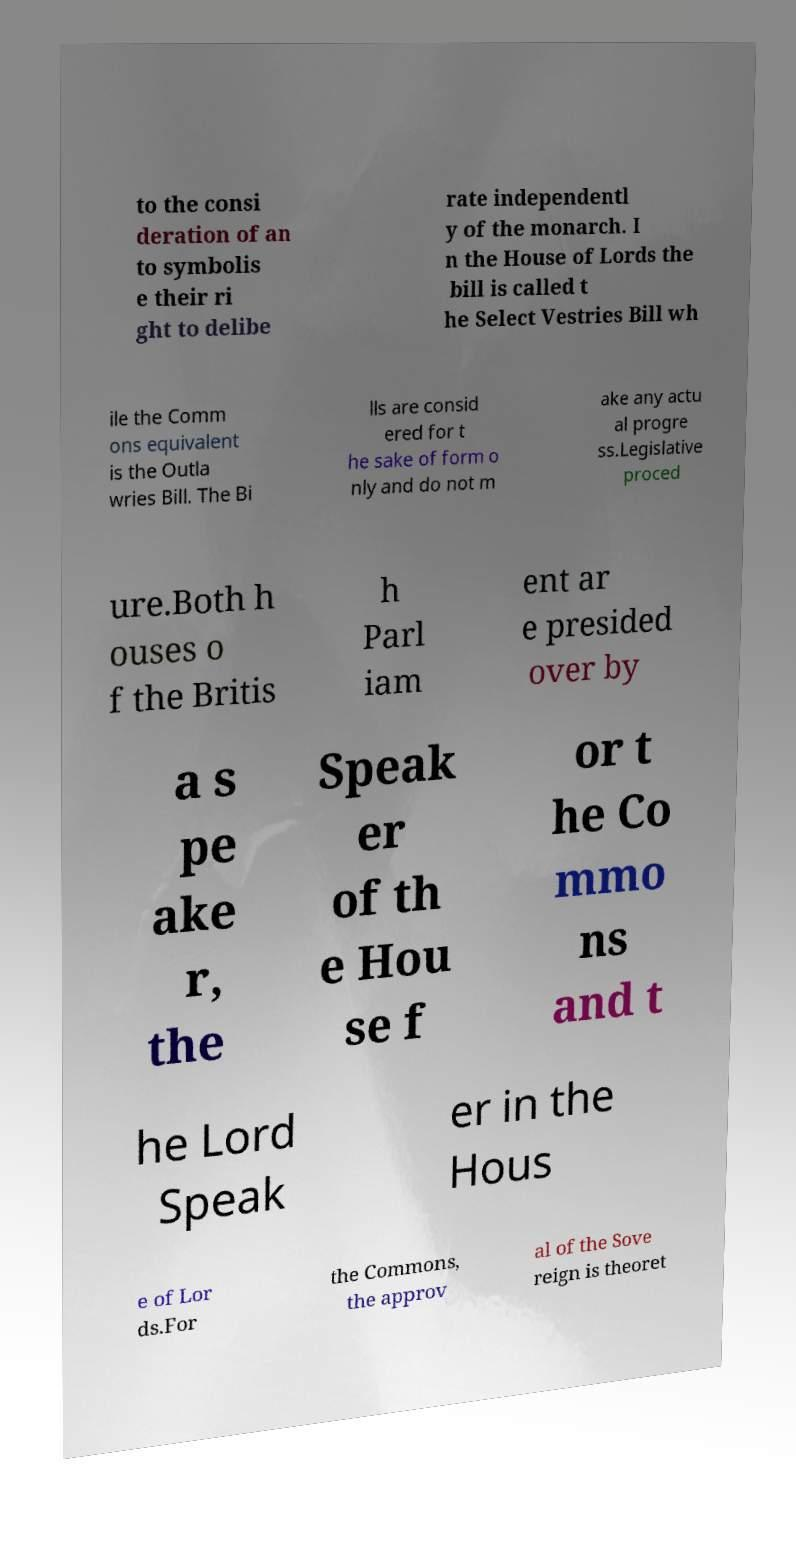Please read and relay the text visible in this image. What does it say? to the consi deration of an to symbolis e their ri ght to delibe rate independentl y of the monarch. I n the House of Lords the bill is called t he Select Vestries Bill wh ile the Comm ons equivalent is the Outla wries Bill. The Bi lls are consid ered for t he sake of form o nly and do not m ake any actu al progre ss.Legislative proced ure.Both h ouses o f the Britis h Parl iam ent ar e presided over by a s pe ake r, the Speak er of th e Hou se f or t he Co mmo ns and t he Lord Speak er in the Hous e of Lor ds.For the Commons, the approv al of the Sove reign is theoret 